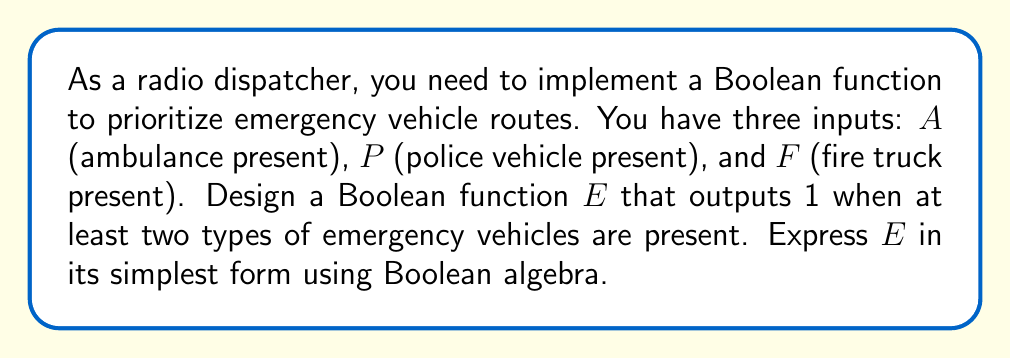Give your solution to this math problem. To solve this problem, we'll follow these steps:

1) First, let's write out the truth table for the function $E$:

   $A$ | $P$ | $F$ | $E$
   ----+-----+-----+----
   0   | 0   | 0   | 0
   0   | 0   | 1   | 0
   0   | 1   | 0   | 0
   0   | 1   | 1   | 1
   1   | 0   | 0   | 0
   1   | 0   | 1   | 1
   1   | 1   | 0   | 1
   1   | 1   | 1   | 1

2) From the truth table, we can write the function in its sum-of-products form:

   $E = A'PF + AP'F + APF' + APF$

3) We can simplify this using Boolean algebra laws:

   $E = A'PF + AP'F + APF' + APF$
   $= A'PF + AP(F' + F) + AP'F$
   $= A'PF + AP + AP'F$

4) Using the distributive law:

   $E = PF(A' + A) + AP'F$
   $= PF + AP'F$

5) This is the simplest form of the function $E$.
Answer: $E = PF + AP'F$ 